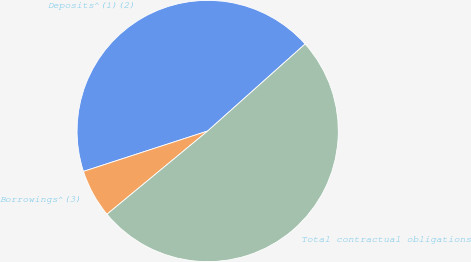<chart> <loc_0><loc_0><loc_500><loc_500><pie_chart><fcel>Deposits^(1)(2)<fcel>Borrowings^(3)<fcel>Total contractual obligations<nl><fcel>43.41%<fcel>5.99%<fcel>50.61%<nl></chart> 